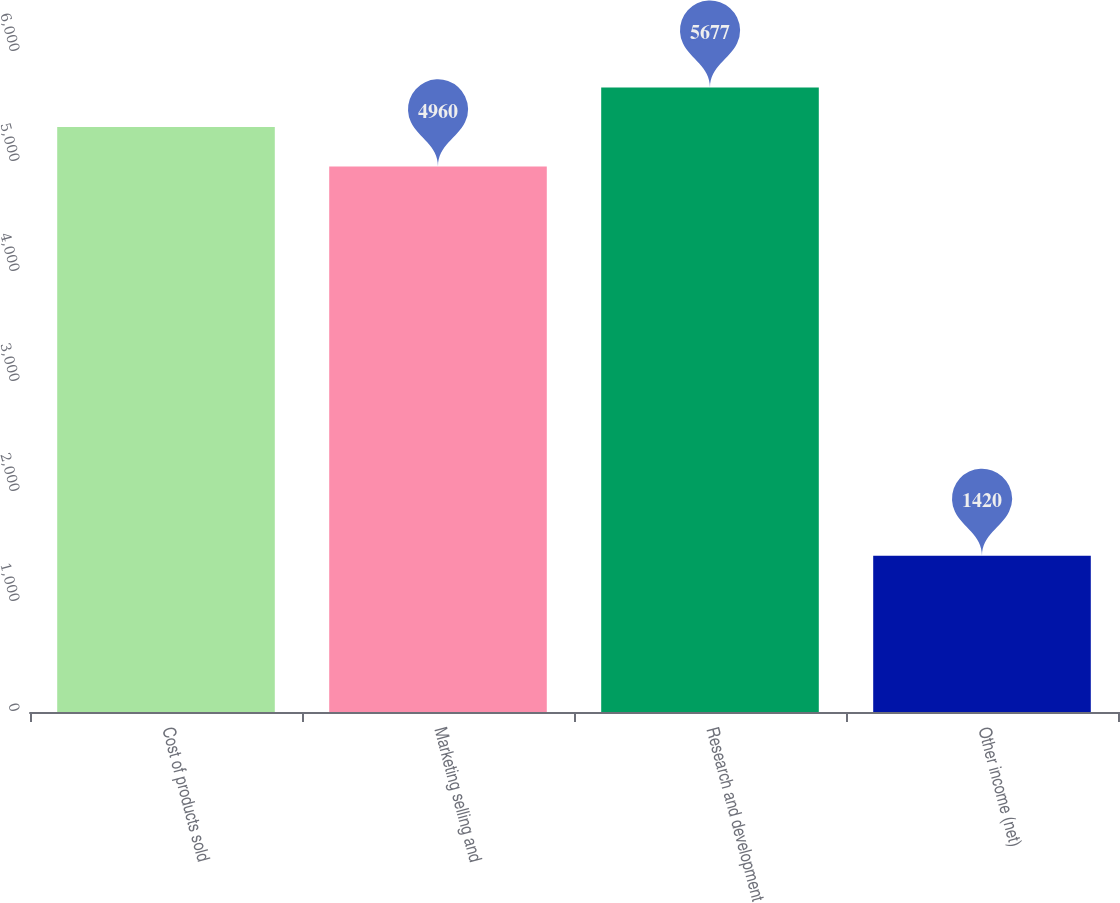<chart> <loc_0><loc_0><loc_500><loc_500><bar_chart><fcel>Cost of products sold<fcel>Marketing selling and<fcel>Research and development<fcel>Other income (net)<nl><fcel>5318.5<fcel>4960<fcel>5677<fcel>1420<nl></chart> 